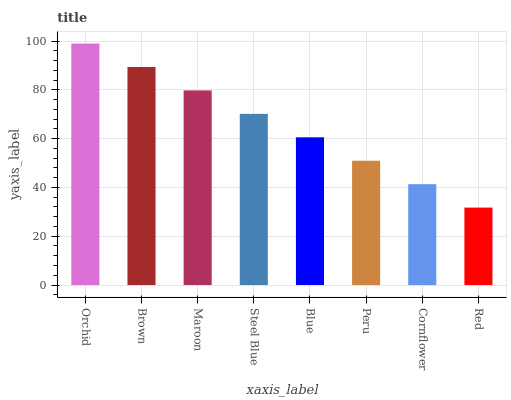Is Red the minimum?
Answer yes or no. Yes. Is Orchid the maximum?
Answer yes or no. Yes. Is Brown the minimum?
Answer yes or no. No. Is Brown the maximum?
Answer yes or no. No. Is Orchid greater than Brown?
Answer yes or no. Yes. Is Brown less than Orchid?
Answer yes or no. Yes. Is Brown greater than Orchid?
Answer yes or no. No. Is Orchid less than Brown?
Answer yes or no. No. Is Steel Blue the high median?
Answer yes or no. Yes. Is Blue the low median?
Answer yes or no. Yes. Is Red the high median?
Answer yes or no. No. Is Brown the low median?
Answer yes or no. No. 